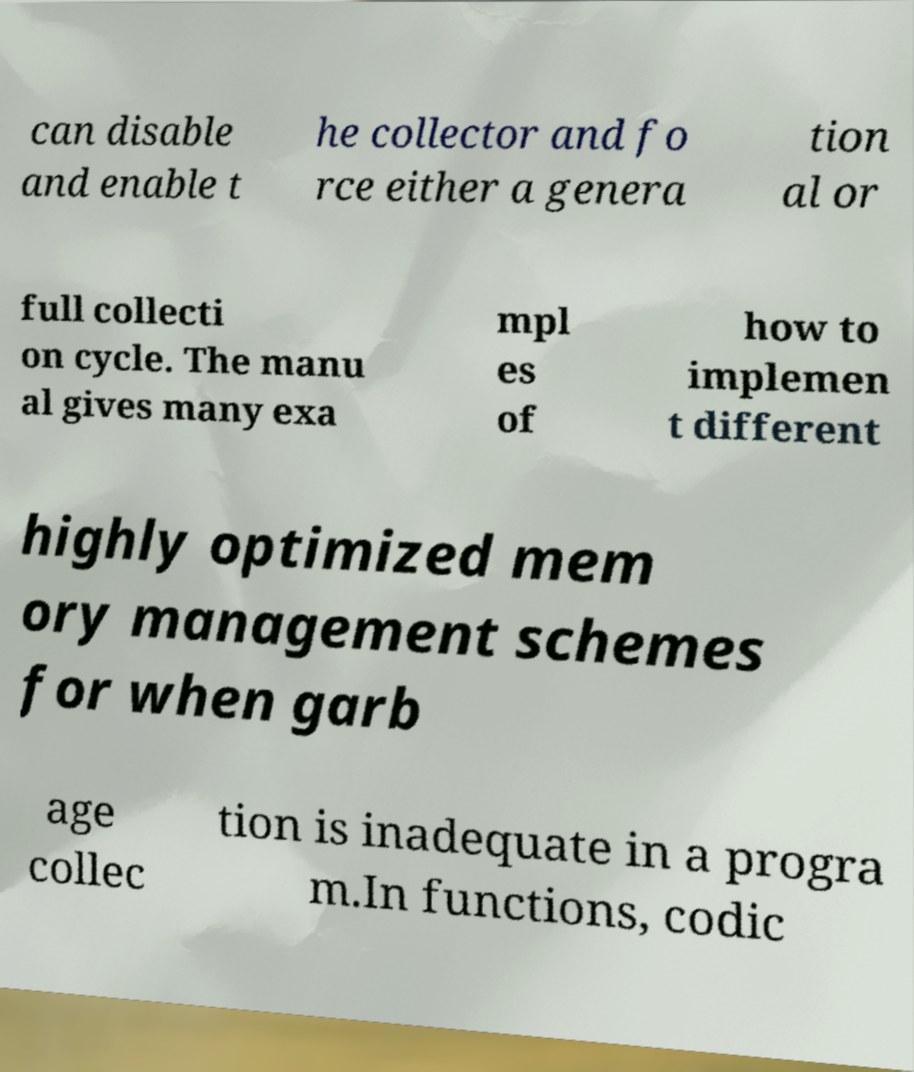Please read and relay the text visible in this image. What does it say? can disable and enable t he collector and fo rce either a genera tion al or full collecti on cycle. The manu al gives many exa mpl es of how to implemen t different highly optimized mem ory management schemes for when garb age collec tion is inadequate in a progra m.In functions, codic 